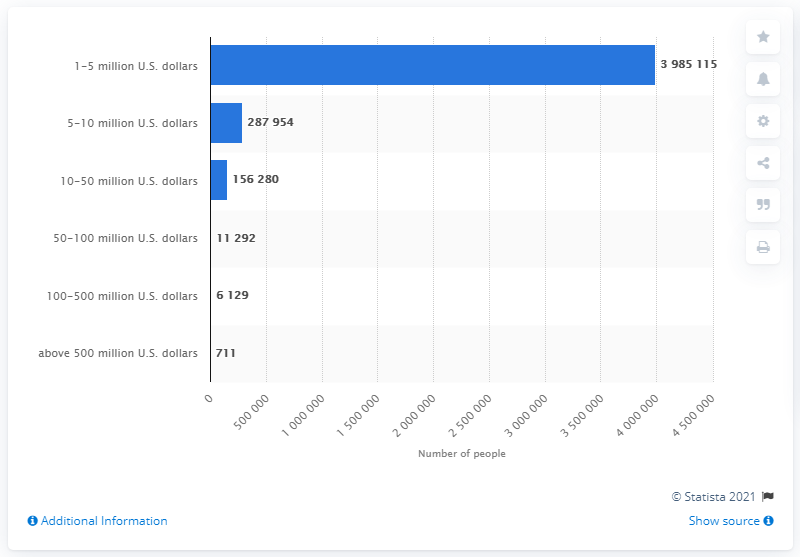Give some essential details in this illustration. In 2019, approximately 711 people in China had more than 500 million dollars worth of assets. 